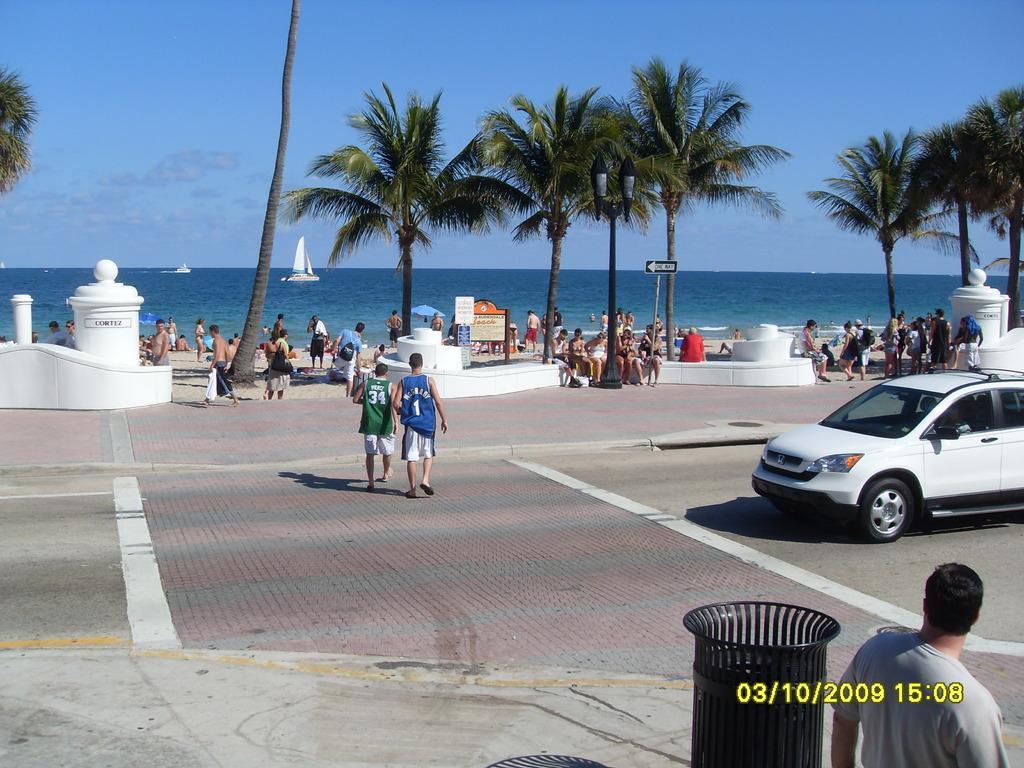Please provide a concise description of this image. In this image there are a few people standing and few people are walking and there is a car. On the right side of the image there is a person standing, beside the person there is an object. In the background there are trees, few boats on the river and a sky. 